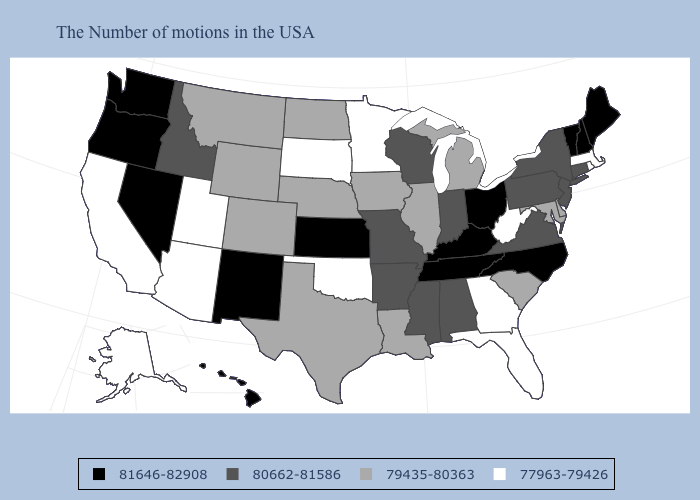Among the states that border Washington , which have the lowest value?
Write a very short answer. Idaho. Among the states that border New Mexico , which have the highest value?
Be succinct. Texas, Colorado. Which states have the lowest value in the USA?
Short answer required. Massachusetts, Rhode Island, West Virginia, Florida, Georgia, Minnesota, Oklahoma, South Dakota, Utah, Arizona, California, Alaska. Which states hav the highest value in the Northeast?
Short answer required. Maine, New Hampshire, Vermont. What is the highest value in the Northeast ?
Give a very brief answer. 81646-82908. Does Alaska have the highest value in the West?
Write a very short answer. No. What is the lowest value in the South?
Keep it brief. 77963-79426. Does the first symbol in the legend represent the smallest category?
Give a very brief answer. No. Does California have the same value as Wyoming?
Be succinct. No. Which states have the highest value in the USA?
Keep it brief. Maine, New Hampshire, Vermont, North Carolina, Ohio, Kentucky, Tennessee, Kansas, New Mexico, Nevada, Washington, Oregon, Hawaii. What is the value of Maine?
Answer briefly. 81646-82908. What is the value of Pennsylvania?
Write a very short answer. 80662-81586. How many symbols are there in the legend?
Quick response, please. 4. Which states hav the highest value in the South?
Answer briefly. North Carolina, Kentucky, Tennessee. Among the states that border New Jersey , does Pennsylvania have the lowest value?
Answer briefly. No. 